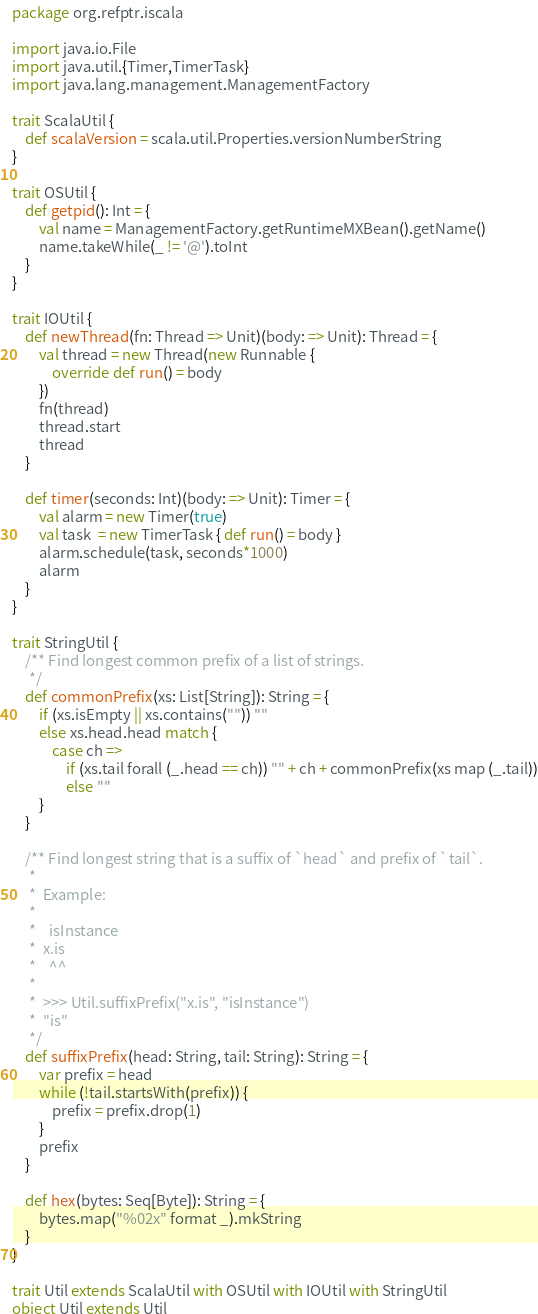Convert code to text. <code><loc_0><loc_0><loc_500><loc_500><_Scala_>package org.refptr.iscala

import java.io.File
import java.util.{Timer,TimerTask}
import java.lang.management.ManagementFactory

trait ScalaUtil {
    def scalaVersion = scala.util.Properties.versionNumberString
}

trait OSUtil {
    def getpid(): Int = {
        val name = ManagementFactory.getRuntimeMXBean().getName()
        name.takeWhile(_ != '@').toInt
    }
}

trait IOUtil {
    def newThread(fn: Thread => Unit)(body: => Unit): Thread = {
        val thread = new Thread(new Runnable {
            override def run() = body
        })
        fn(thread)
        thread.start
        thread
    }

    def timer(seconds: Int)(body: => Unit): Timer = {
        val alarm = new Timer(true)
        val task  = new TimerTask { def run() = body }
        alarm.schedule(task, seconds*1000)
        alarm
    }
}

trait StringUtil {
    /** Find longest common prefix of a list of strings.
     */
    def commonPrefix(xs: List[String]): String = {
        if (xs.isEmpty || xs.contains("")) ""
        else xs.head.head match {
            case ch =>
                if (xs.tail forall (_.head == ch)) "" + ch + commonPrefix(xs map (_.tail))
                else ""
        }
    }

    /** Find longest string that is a suffix of `head` and prefix of `tail`.
     *
     *  Example:
     *
     *    isInstance
     *  x.is
     *    ^^
     *
     *  >>> Util.suffixPrefix("x.is", "isInstance")
     *  "is"
     */
    def suffixPrefix(head: String, tail: String): String = {
        var prefix = head
        while (!tail.startsWith(prefix)) {
            prefix = prefix.drop(1)
        }
        prefix
    }

    def hex(bytes: Seq[Byte]): String = {
        bytes.map("%02x" format _).mkString
    }
}

trait Util extends ScalaUtil with OSUtil with IOUtil with StringUtil
object Util extends Util
</code> 